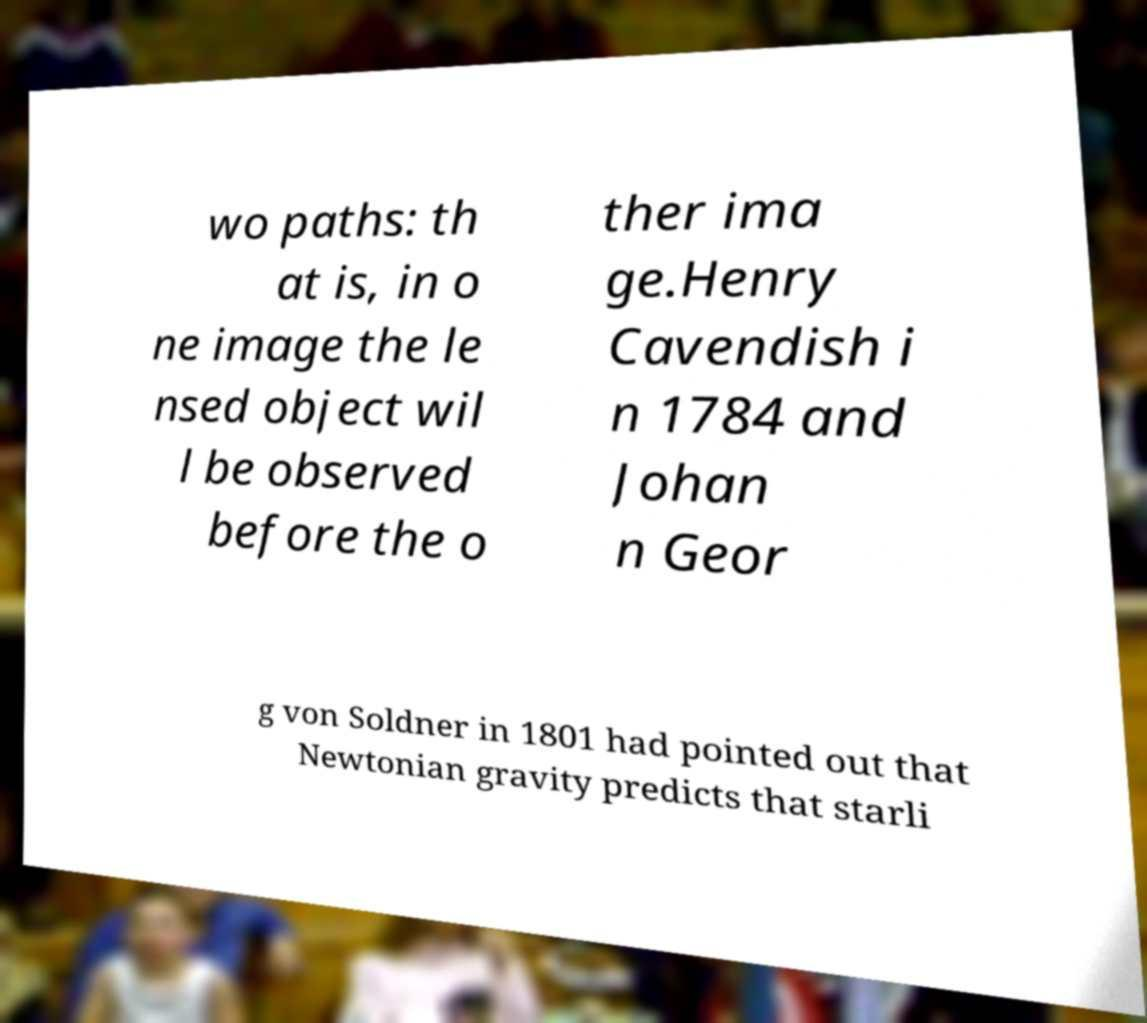Could you assist in decoding the text presented in this image and type it out clearly? wo paths: th at is, in o ne image the le nsed object wil l be observed before the o ther ima ge.Henry Cavendish i n 1784 and Johan n Geor g von Soldner in 1801 had pointed out that Newtonian gravity predicts that starli 